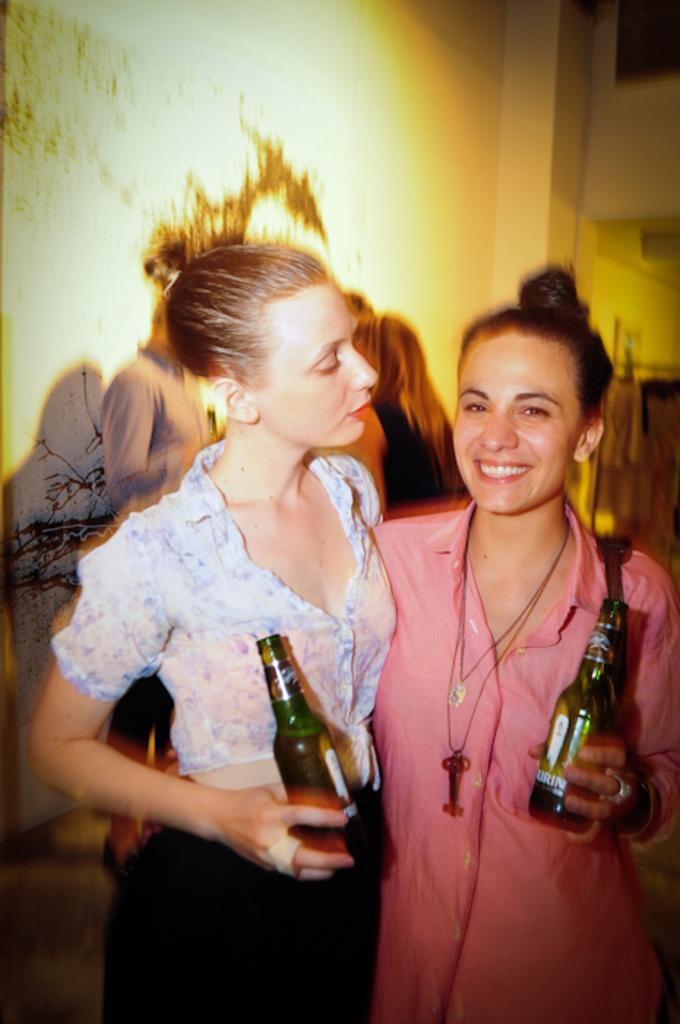How many women are in the image? There are two women in the image. What are the women doing in the image? The women are standing and holding beer bottles in their hands. Can you describe the background of the image? There are people in the background of the image. What type of planes can be seen flying in the image? There are no planes visible in the image. 